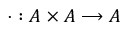<formula> <loc_0><loc_0><loc_500><loc_500>\cdot \colon A \times A \longrightarrow A</formula> 